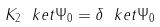Convert formula to latex. <formula><loc_0><loc_0><loc_500><loc_500>K _ { 2 } \ k e t { \Psi _ { 0 } } = \delta \ k e t { \Psi _ { 0 } }</formula> 